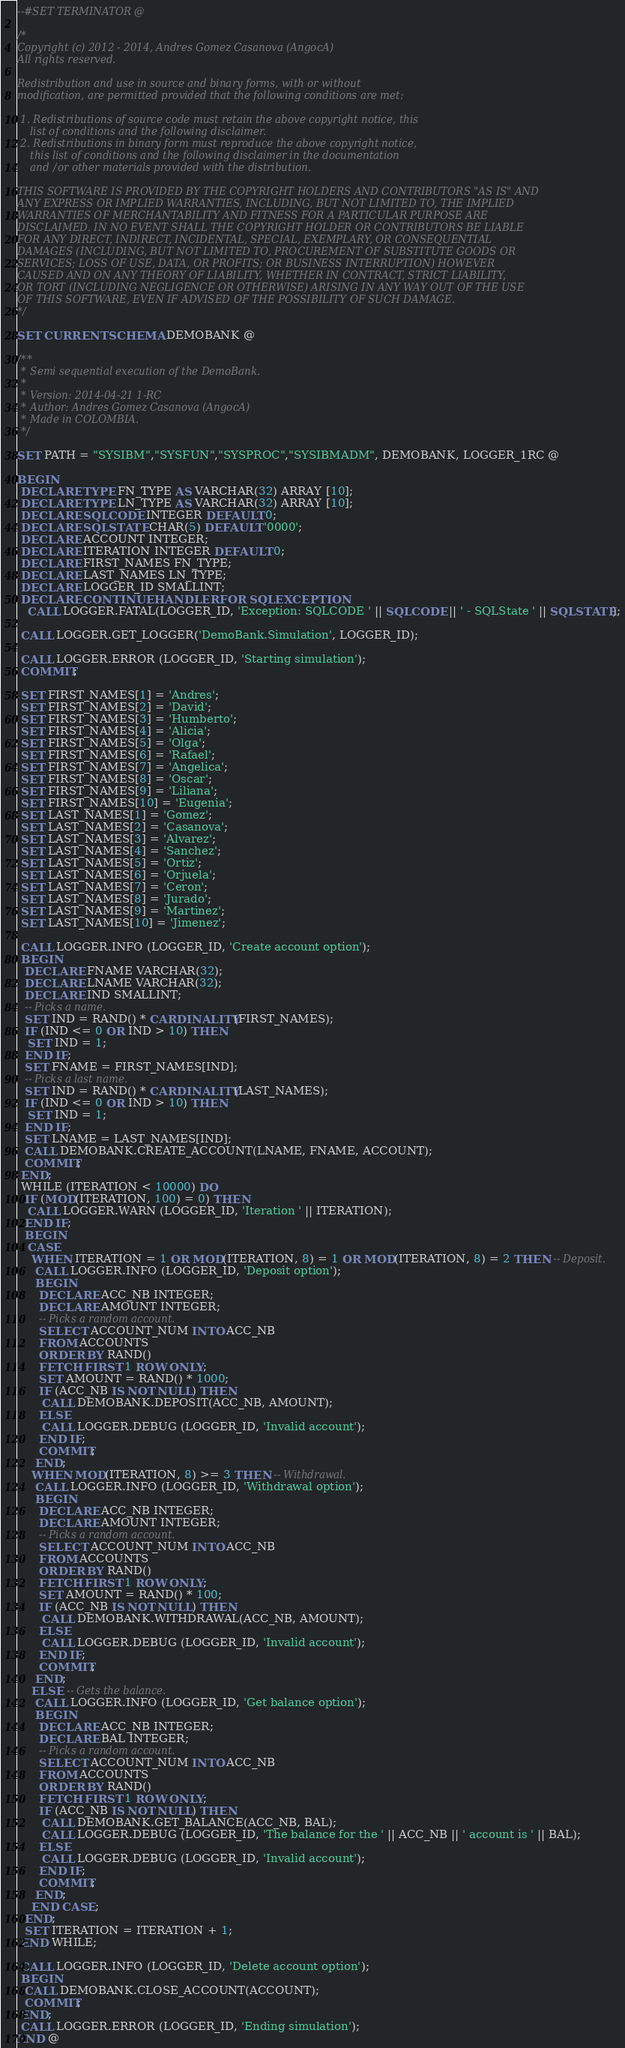<code> <loc_0><loc_0><loc_500><loc_500><_SQL_>--#SET TERMINATOR @

/*
Copyright (c) 2012 - 2014, Andres Gomez Casanova (AngocA)
All rights reserved.

Redistribution and use in source and binary forms, with or without
modification, are permitted provided that the following conditions are met:

 1. Redistributions of source code must retain the above copyright notice, this
    list of conditions and the following disclaimer.
 2. Redistributions in binary form must reproduce the above copyright notice,
    this list of conditions and the following disclaimer in the documentation
    and/or other materials provided with the distribution.

THIS SOFTWARE IS PROVIDED BY THE COPYRIGHT HOLDERS AND CONTRIBUTORS "AS IS" AND
ANY EXPRESS OR IMPLIED WARRANTIES, INCLUDING, BUT NOT LIMITED TO, THE IMPLIED
WARRANTIES OF MERCHANTABILITY AND FITNESS FOR A PARTICULAR PURPOSE ARE
DISCLAIMED. IN NO EVENT SHALL THE COPYRIGHT HOLDER OR CONTRIBUTORS BE LIABLE
FOR ANY DIRECT, INDIRECT, INCIDENTAL, SPECIAL, EXEMPLARY, OR CONSEQUENTIAL
DAMAGES (INCLUDING, BUT NOT LIMITED TO, PROCUREMENT OF SUBSTITUTE GOODS OR
SERVICES; LOSS OF USE, DATA, OR PROFITS; OR BUSINESS INTERRUPTION) HOWEVER
CAUSED AND ON ANY THEORY OF LIABILITY, WHETHER IN CONTRACT, STRICT LIABILITY,
OR TORT (INCLUDING NEGLIGENCE OR OTHERWISE) ARISING IN ANY WAY OUT OF THE USE
OF THIS SOFTWARE, EVEN IF ADVISED OF THE POSSIBILITY OF SUCH DAMAGE.
*/

SET CURRENT SCHEMA DEMOBANK @

/**
 * Semi sequential execution of the DemoBank.
 *
 * Version: 2014-04-21 1-RC
 * Author: Andres Gomez Casanova (AngocA)
 * Made in COLOMBIA.
 */

SET PATH = "SYSIBM","SYSFUN","SYSPROC","SYSIBMADM", DEMOBANK, LOGGER_1RC @

BEGIN
 DECLARE TYPE FN_TYPE AS VARCHAR(32) ARRAY [10];
 DECLARE TYPE LN_TYPE AS VARCHAR(32) ARRAY [10];
 DECLARE SQLCODE INTEGER DEFAULT 0;
 DECLARE SQLSTATE CHAR(5) DEFAULT '0000';
 DECLARE ACCOUNT INTEGER;
 DECLARE ITERATION INTEGER DEFAULT 0;
 DECLARE FIRST_NAMES FN_TYPE;
 DECLARE LAST_NAMES LN_TYPE;
 DECLARE LOGGER_ID SMALLINT;
 DECLARE CONTINUE HANDLER FOR SQLEXCEPTION
   CALL LOGGER.FATAL(LOGGER_ID, 'Exception: SQLCODE ' || SQLCODE || ' - SQLState ' || SQLSTATE);

 CALL LOGGER.GET_LOGGER('DemoBank.Simulation', LOGGER_ID);

 CALL LOGGER.ERROR (LOGGER_ID, 'Starting simulation');
 COMMIT;

 SET FIRST_NAMES[1] = 'Andres';
 SET FIRST_NAMES[2] = 'David';
 SET FIRST_NAMES[3] = 'Humberto';
 SET FIRST_NAMES[4] = 'Alicia';
 SET FIRST_NAMES[5] = 'Olga';
 SET FIRST_NAMES[6] = 'Rafael';
 SET FIRST_NAMES[7] = 'Angelica';
 SET FIRST_NAMES[8] = 'Oscar';
 SET FIRST_NAMES[9] = 'Liliana';
 SET FIRST_NAMES[10] = 'Eugenia';
 SET LAST_NAMES[1] = 'Gomez';
 SET LAST_NAMES[2] = 'Casanova';
 SET LAST_NAMES[3] = 'Alvarez';
 SET LAST_NAMES[4] = 'Sanchez';
 SET LAST_NAMES[5] = 'Ortiz';
 SET LAST_NAMES[6] = 'Orjuela';
 SET LAST_NAMES[7] = 'Ceron';
 SET LAST_NAMES[8] = 'Jurado';
 SET LAST_NAMES[9] = 'Martinez';
 SET LAST_NAMES[10] = 'Jimenez';

 CALL LOGGER.INFO (LOGGER_ID, 'Create account option');
 BEGIN
  DECLARE FNAME VARCHAR(32);
  DECLARE LNAME VARCHAR(32);
  DECLARE IND SMALLINT;
  -- Picks a name.
  SET IND = RAND() * CARDINALITY(FIRST_NAMES);
  IF (IND <= 0 OR IND > 10) THEN
   SET IND = 1;
  END IF;
  SET FNAME = FIRST_NAMES[IND];
  -- Picks a last name.
  SET IND = RAND() * CARDINALITY(LAST_NAMES);
  IF (IND <= 0 OR IND > 10) THEN
   SET IND = 1;
  END IF;
  SET LNAME = LAST_NAMES[IND];
  CALL DEMOBANK.CREATE_ACCOUNT(LNAME, FNAME, ACCOUNT);
  COMMIT;
 END;
 WHILE (ITERATION < 10000) DO
  IF (MOD(ITERATION, 100) = 0) THEN
   CALL LOGGER.WARN (LOGGER_ID, 'Iteration ' || ITERATION);
  END IF;
  BEGIN
   CASE
    WHEN ITERATION = 1 OR MOD(ITERATION, 8) = 1 OR MOD(ITERATION, 8) = 2 THEN -- Deposit.
     CALL LOGGER.INFO (LOGGER_ID, 'Deposit option');
     BEGIN
      DECLARE ACC_NB INTEGER;
      DECLARE AMOUNT INTEGER;
      -- Picks a random account.
      SELECT ACCOUNT_NUM INTO ACC_NB
      FROM ACCOUNTS
      ORDER BY RAND()
      FETCH FIRST 1 ROW ONLY;
      SET AMOUNT = RAND() * 1000;
      IF (ACC_NB IS NOT NULL) THEN
       CALL DEMOBANK.DEPOSIT(ACC_NB, AMOUNT);
      ELSE
       CALL LOGGER.DEBUG (LOGGER_ID, 'Invalid account');
      END IF;
      COMMIT;
     END;
    WHEN MOD(ITERATION, 8) >= 3 THEN -- Withdrawal.
     CALL LOGGER.INFO (LOGGER_ID, 'Withdrawal option');
     BEGIN
      DECLARE ACC_NB INTEGER;
      DECLARE AMOUNT INTEGER;
      -- Picks a random account.
      SELECT ACCOUNT_NUM INTO ACC_NB
      FROM ACCOUNTS
      ORDER BY RAND()
      FETCH FIRST 1 ROW ONLY;
      SET AMOUNT = RAND() * 100;
      IF (ACC_NB IS NOT NULL) THEN
       CALL DEMOBANK.WITHDRAWAL(ACC_NB, AMOUNT);
      ELSE
       CALL LOGGER.DEBUG (LOGGER_ID, 'Invalid account');
      END IF;
      COMMIT;
     END;
    ELSE -- Gets the balance.
     CALL LOGGER.INFO (LOGGER_ID, 'Get balance option');
     BEGIN
      DECLARE ACC_NB INTEGER;
      DECLARE BAL INTEGER;
      -- Picks a random account.
      SELECT ACCOUNT_NUM INTO ACC_NB
      FROM ACCOUNTS
      ORDER BY RAND()
      FETCH FIRST 1 ROW ONLY;
      IF (ACC_NB IS NOT NULL) THEN
       CALL DEMOBANK.GET_BALANCE(ACC_NB, BAL);
       CALL LOGGER.DEBUG (LOGGER_ID, 'The balance for the ' || ACC_NB || ' account is ' || BAL);
      ELSE
       CALL LOGGER.DEBUG (LOGGER_ID, 'Invalid account');
      END IF;
      COMMIT;
     END;
    END CASE;
  END;
  SET ITERATION = ITERATION + 1;
 END WHILE;

 CALL LOGGER.INFO (LOGGER_ID, 'Delete account option');
 BEGIN
  CALL DEMOBANK.CLOSE_ACCOUNT(ACCOUNT);
  COMMIT;
 END;
 CALL LOGGER.ERROR (LOGGER_ID, 'Ending simulation');
END @

</code> 